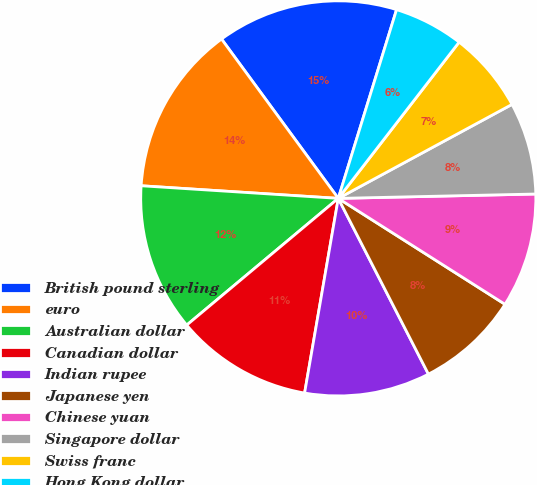Convert chart to OTSL. <chart><loc_0><loc_0><loc_500><loc_500><pie_chart><fcel>British pound sterling<fcel>euro<fcel>Australian dollar<fcel>Canadian dollar<fcel>Indian rupee<fcel>Japanese yen<fcel>Chinese yuan<fcel>Singapore dollar<fcel>Swiss franc<fcel>Hong Kong dollar<nl><fcel>14.83%<fcel>13.92%<fcel>12.1%<fcel>11.19%<fcel>10.27%<fcel>8.45%<fcel>9.36%<fcel>7.54%<fcel>6.63%<fcel>5.71%<nl></chart> 